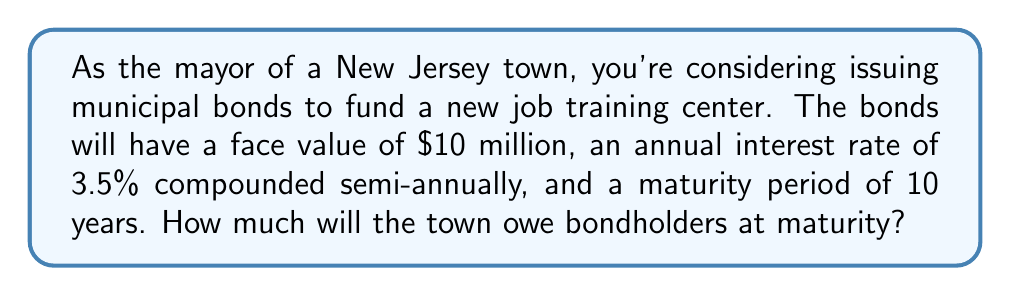Teach me how to tackle this problem. To solve this problem, we'll use the compound interest formula:

$$A = P(1 + \frac{r}{n})^{nt}$$

Where:
$A$ = Final amount
$P$ = Principal (initial investment)
$r$ = Annual interest rate (in decimal form)
$n$ = Number of times interest is compounded per year
$t$ = Number of years

Given:
$P = \$10,000,000$
$r = 0.035$ (3.5% converted to decimal)
$n = 2$ (compounded semi-annually)
$t = 10$ years

Let's substitute these values into the formula:

$$A = 10,000,000(1 + \frac{0.035}{2})^{2(10)}$$

$$A = 10,000,000(1 + 0.0175)^{20}$$

$$A = 10,000,000(1.0175)^{20}$$

Using a calculator or computer:

$$A = 10,000,000 * 1.4185762242$$

$$A = 14,185,762.24$$
Answer: $14,185,762.24 